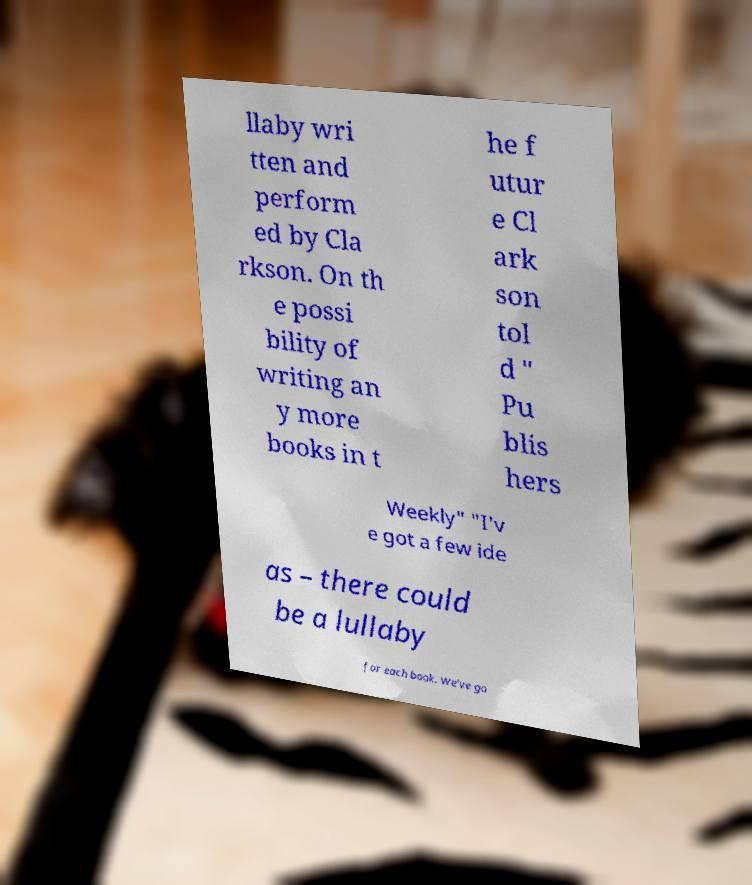I need the written content from this picture converted into text. Can you do that? llaby wri tten and perform ed by Cla rkson. On th e possi bility of writing an y more books in t he f utur e Cl ark son tol d " Pu blis hers Weekly" "I'v e got a few ide as – there could be a lullaby for each book. We've go 